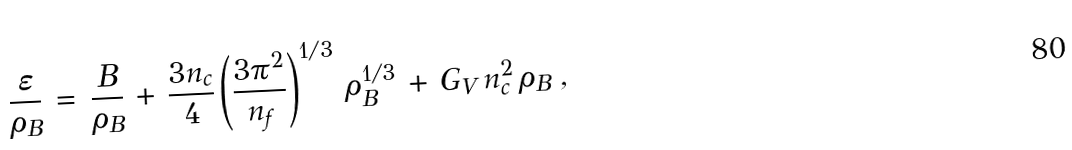Convert formula to latex. <formula><loc_0><loc_0><loc_500><loc_500>\frac { \varepsilon } { \rho _ { B } } \, = \, \frac { B } { \rho _ { B } } \, + \, \frac { 3 n _ { c } } { 4 } \left ( \frac { 3 \pi ^ { 2 } } { n _ { f } } \right ) ^ { 1 / 3 } \, \rho _ { B } ^ { 1 / 3 } \, + \, G _ { V } \, n _ { c } ^ { 2 } \, \rho _ { B } \ ,</formula> 